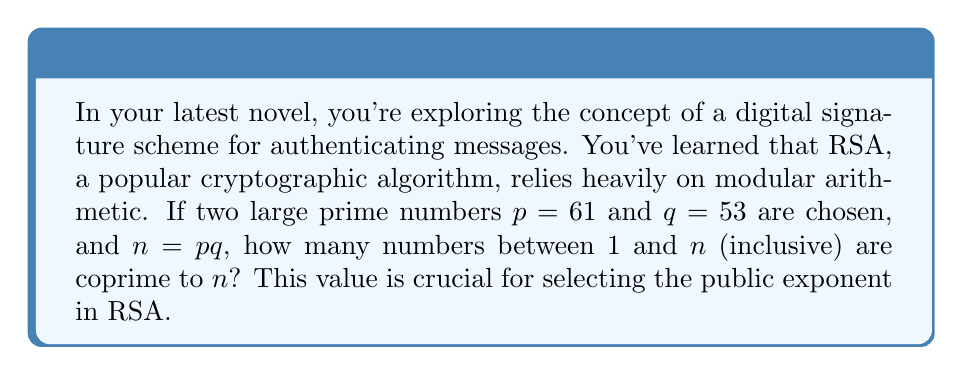Give your solution to this math problem. To solve this problem, we need to use the Euler's totient function, denoted as $\phi(n)$, which is fundamental in modular arithmetic and RSA cryptography. Here's the step-by-step solution:

1) First, we calculate $n$:
   $n = p \times q = 61 \times 53 = 3233$

2) For a number $n$ that is the product of two distinct primes $p$ and $q$, the Euler's totient function is given by:
   $\phi(n) = \phi(p) \times \phi(q) = (p-1) \times (q-1)$

3) This is because:
   - For a prime number $p$, all numbers from 1 to $p-1$ are coprime to it.
   - When $n = pq$, we multiply these counts, but we need to subtract 1 to avoid double-counting.

4) So, we calculate:
   $\phi(3233) = (61-1) \times (53-1) = 60 \times 52 = 3120$

This result, 3120, represents the number of integers between 1 and 3233 that are coprime to 3233. In the context of RSA, this value is used to select the public exponent $e$, which must be coprime to $\phi(n)$.
Answer: 3120 